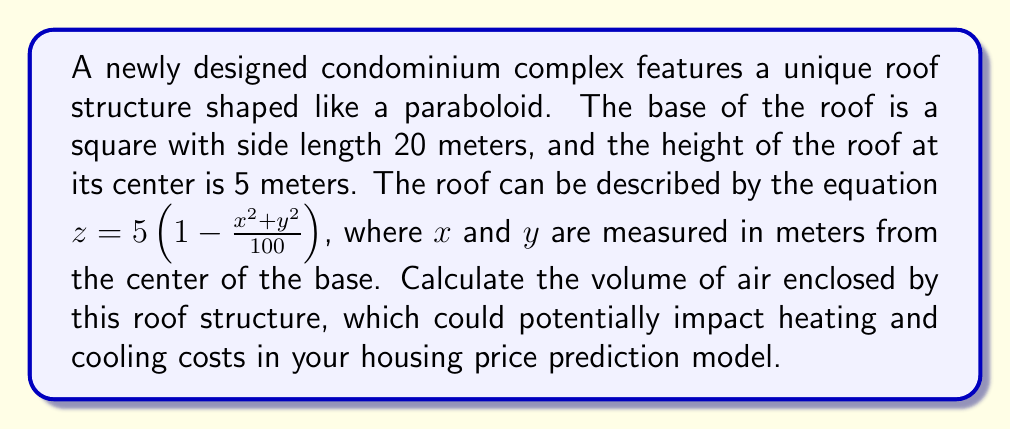Give your solution to this math problem. To solve this problem, we'll use integral calculus to calculate the volume enclosed by the paraboloid roof.

Step 1: Set up the triple integral for the volume.
The volume is given by:
$$V = \int_{-10}^{10} \int_{-10}^{10} \int_0^{5(1-\frac{x^2+y^2}{100})} dz \, dy \, dx$$

Step 2: Evaluate the innermost integral with respect to z.
$$V = \int_{-10}^{10} \int_{-10}^{10} \left[z\right]_0^{5(1-\frac{x^2+y^2}{100})} dy \, dx$$
$$V = \int_{-10}^{10} \int_{-10}^{10} 5(1-\frac{x^2+y^2}{100}) dy \, dx$$

Step 3: Evaluate the integral with respect to y.
$$V = \int_{-10}^{10} \left[5y - \frac{5y^3}{300} - \frac{5x^2y}{100}\right]_{-10}^{10} dx$$
$$V = \int_{-10}^{10} \left(100 - \frac{1000}{300} - \frac{10x^2}{10}\right) dx$$
$$V = \int_{-10}^{10} (100 - \frac{10}{3} - x^2) dx$$

Step 4: Evaluate the final integral with respect to x.
$$V = \left[100x - \frac{10x}{3} - \frac{x^3}{3}\right]_{-10}^{10}$$
$$V = \left(1000 - \frac{100}{3} - \frac{1000}{3}\right) - \left(-1000 + \frac{100}{3} + \frac{1000}{3}\right)$$
$$V = 2000 - \frac{200}{3} - \frac{2000}{3}$$
$$V = 2000 - \frac{2200}{3} = \frac{6000 - 2200}{3} = \frac{3800}{3}$$

Step 5: Simplify the result.
$$V = \frac{3800}{3} \approx 1266.67 \text{ cubic meters}$$
Answer: $\frac{3800}{3}$ cubic meters 